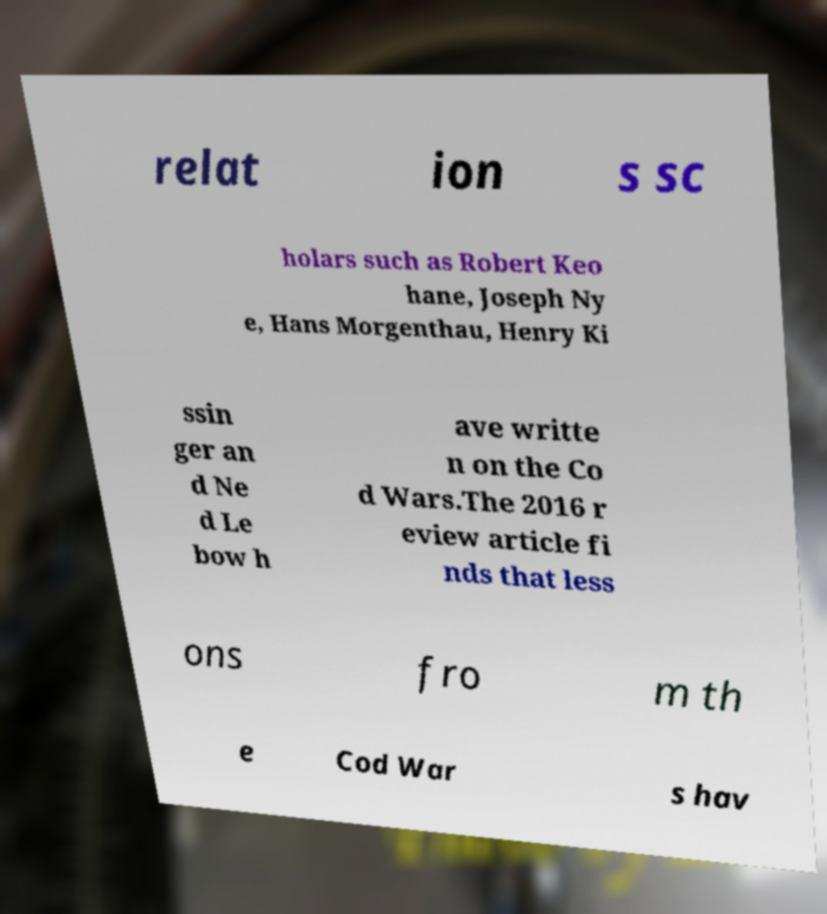Can you read and provide the text displayed in the image?This photo seems to have some interesting text. Can you extract and type it out for me? relat ion s sc holars such as Robert Keo hane, Joseph Ny e, Hans Morgenthau, Henry Ki ssin ger an d Ne d Le bow h ave writte n on the Co d Wars.The 2016 r eview article fi nds that less ons fro m th e Cod War s hav 